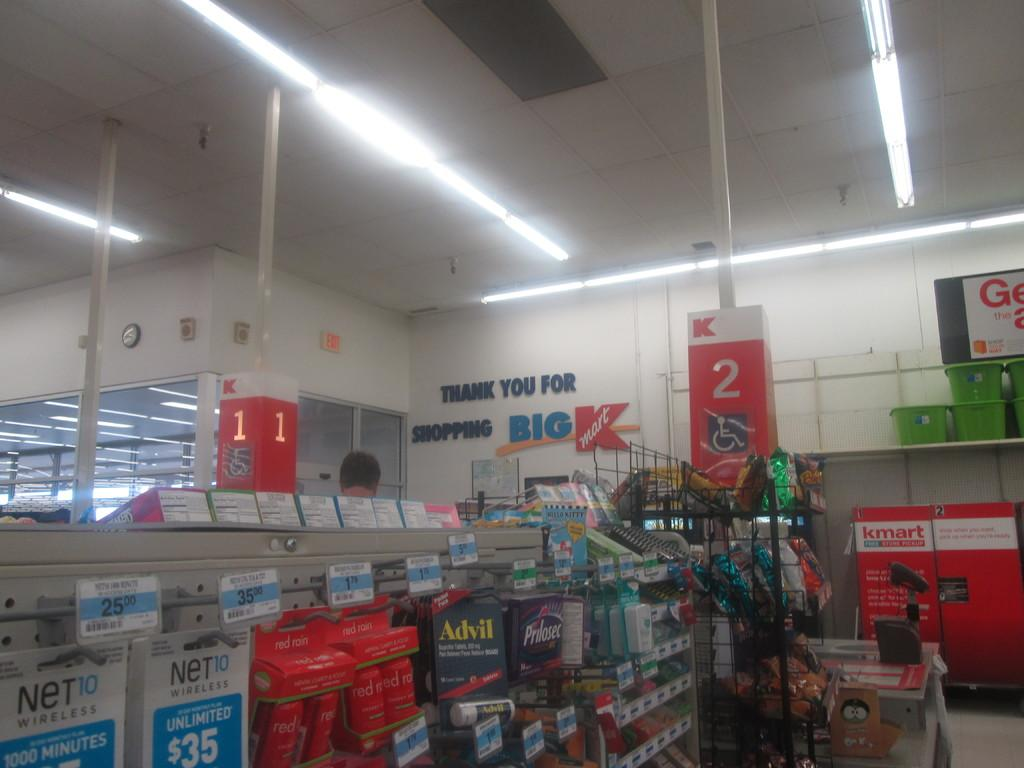Provide a one-sentence caption for the provided image. big kmart store display of the inside of store. 